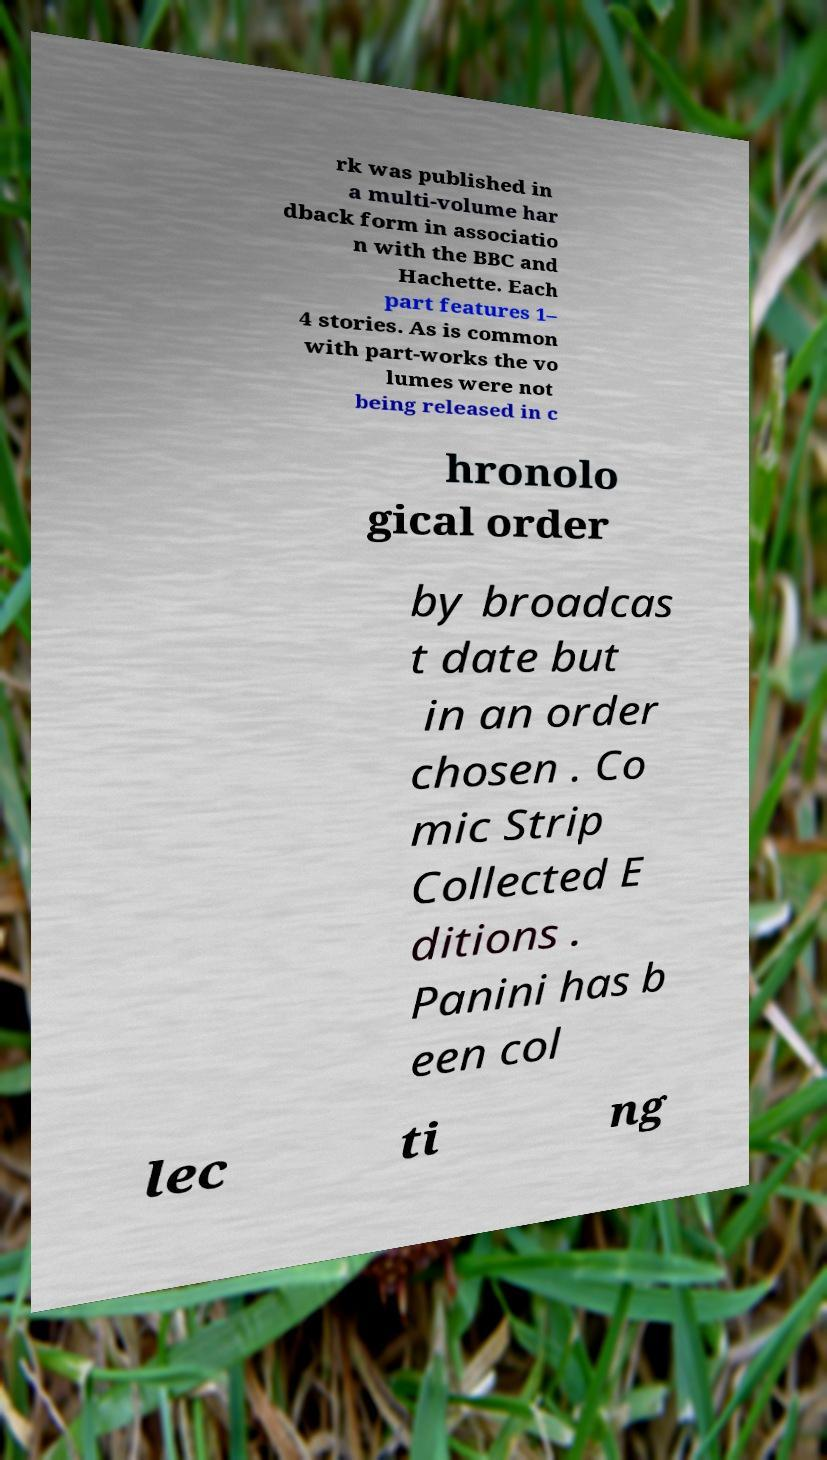For documentation purposes, I need the text within this image transcribed. Could you provide that? rk was published in a multi-volume har dback form in associatio n with the BBC and Hachette. Each part features 1– 4 stories. As is common with part-works the vo lumes were not being released in c hronolo gical order by broadcas t date but in an order chosen . Co mic Strip Collected E ditions . Panini has b een col lec ti ng 